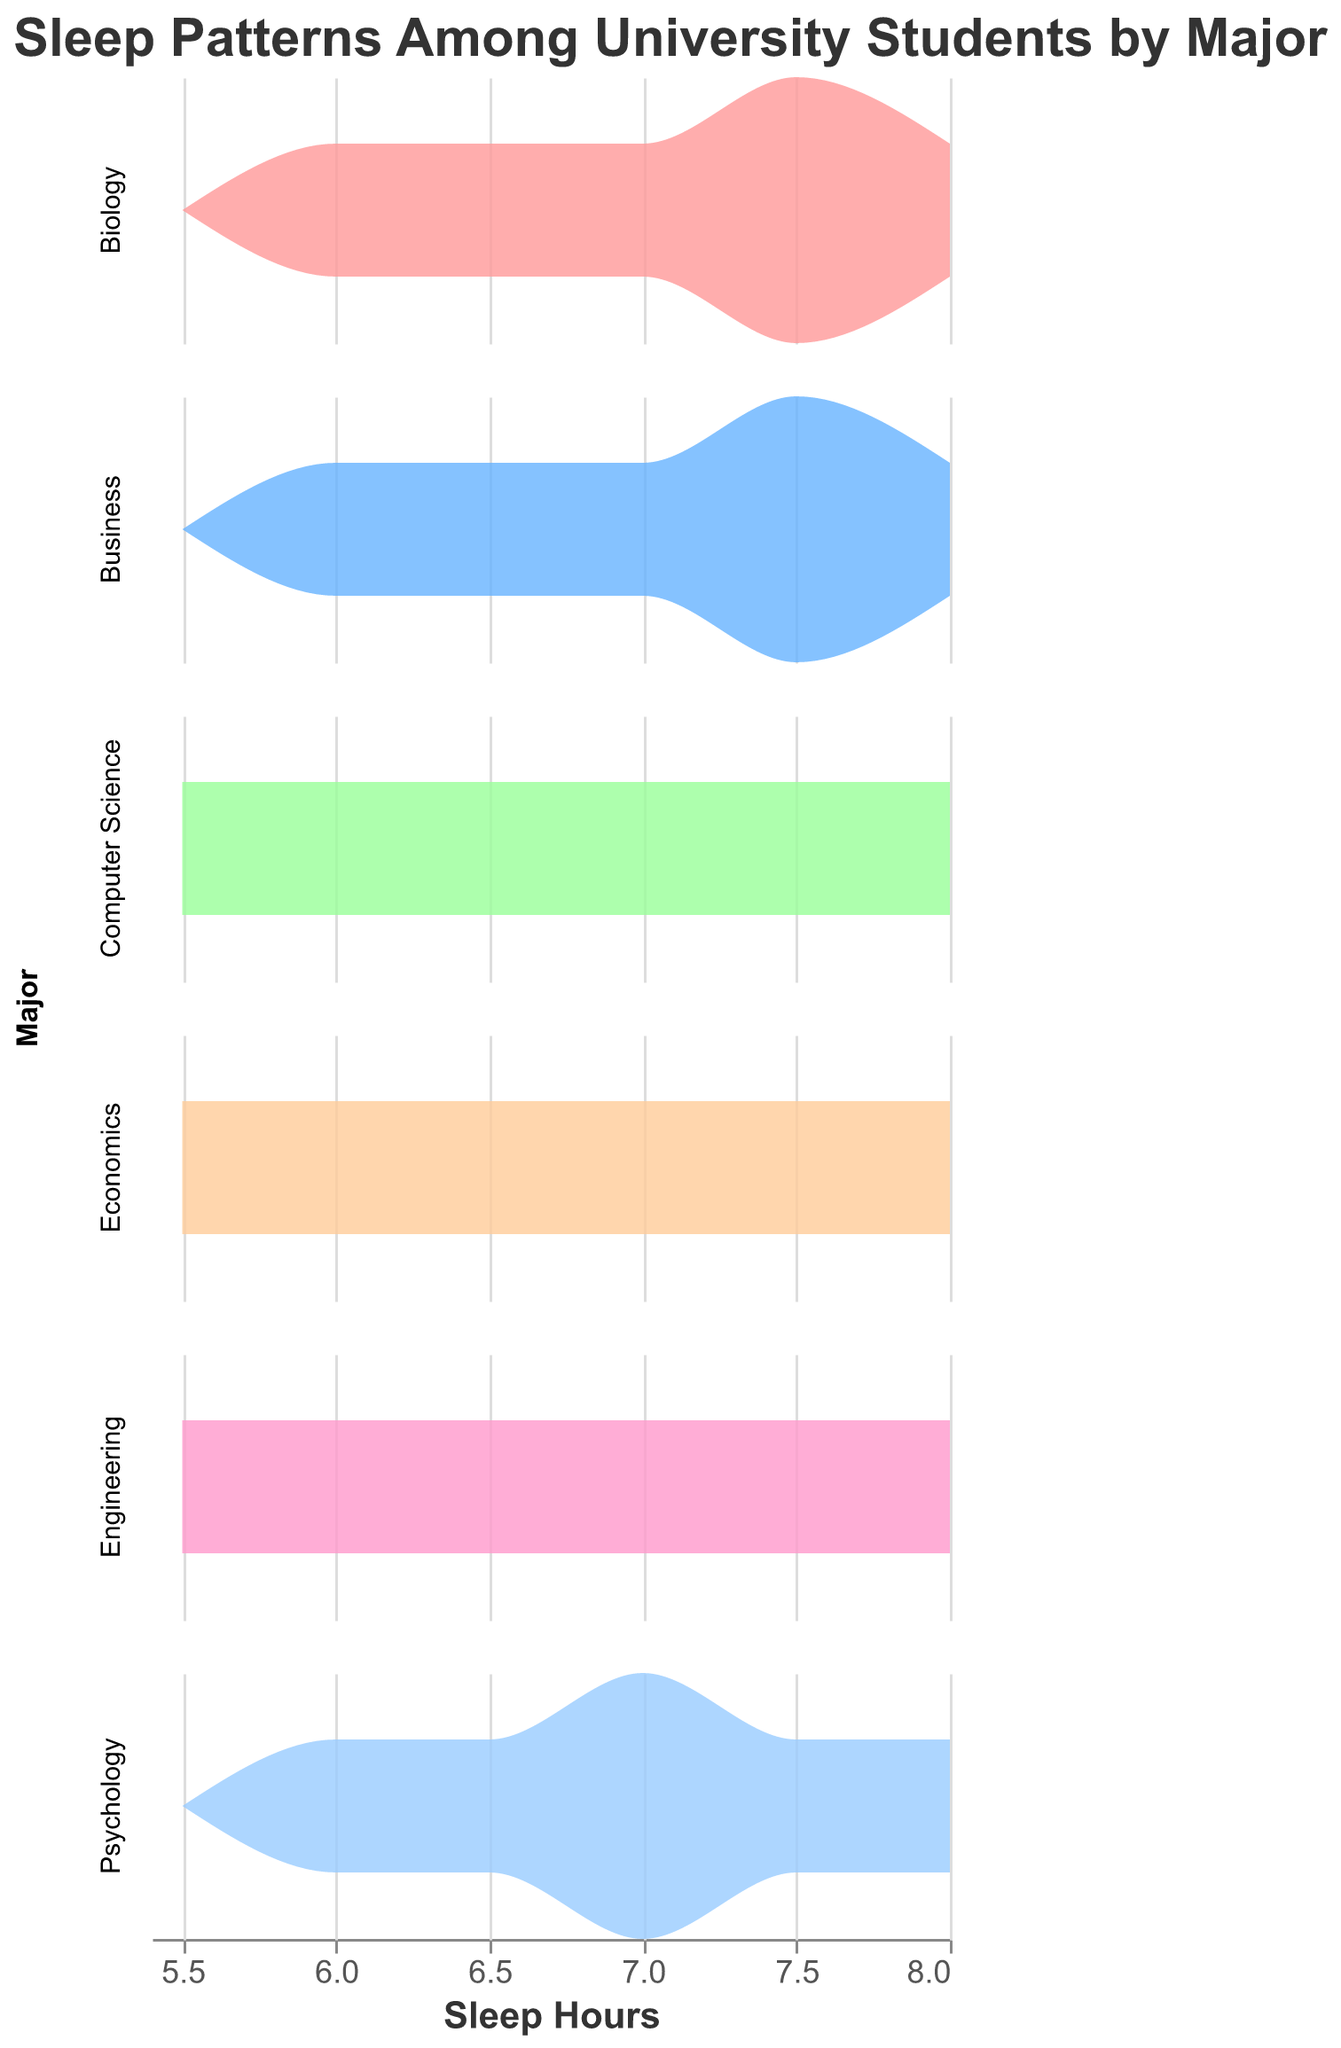What is the title of the figure? The title of the figure is clearly displayed at the top.
Answer: Sleep Patterns Among University Students by Major What is the major with the widest range of sleep hours? By observing the density plots for each major, the major with the widest range of sleep hours extends from 5.5 hours to 8.0 hours.
Answer: Computer Science Which major has the mode (most common) sleep duration close to 7.5 hours? By looking at the density peaks, which represent the most common sleep duration, the major with the peak closest to 7.5 hours is identified.
Answer: Multiple majors: Psychology, Business Between Engineering and Psychology, which group has more students with exactly 7.0 sleep hours? By comparing the density heights at 7.0 sleep hours for both majors, we determine which group has a higher density at this point.
Answer: Psychology Which major appears to have students with a balanced distribution around 7.0 sleep hours? By evaluating the density plots for symmetry and spread around 7.0 sleep hours, the major with a balanced distribution is identified.
Answer: Business Which major's students, by visual densitiy comparison, mostly sleep less than 7 hours? Comparing the higher density areas, the major with denser left-side distribution (below 7 hours) indicates this.
Answer: Computer Science What is the commonality in sleep patterns between Economics and Psychology students? Economics and Psychology both show peaks or higher densities around multiple sleep durations, indicating common sleep patterns.
Answer: Peaks around 6.5 and 7.5 sleep hours If you wanted to recommend majors based on ideal sleep hours (7-8 hours), which majors best fit this criterion? Identifying the majors whose density plots show clustering mostly within the ideal sleep hour range (7-8 hours).
Answer: Biology, Business Between Biology and Economics, which major has more consistency in students' sleep patterns? By comparing the spread of the density plots, the major with a tighter range indicates more consistency.
Answer: Biology Considering the density plots, which major has the least variation in student sleep hours? Recognizing the major with the narrowest spread of its density plot suggests the least variation.
Answer: Psychology 